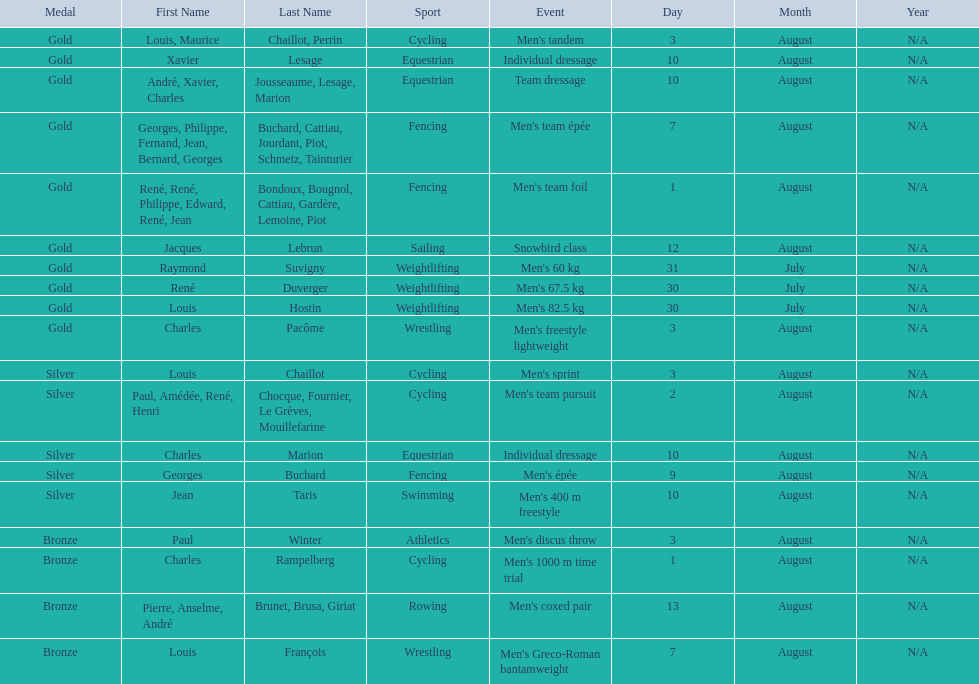What sport is listed first? Cycling. Can you give me this table as a dict? {'header': ['Medal', 'First Name', 'Last Name', 'Sport', 'Event', 'Day', 'Month', 'Year'], 'rows': [['Gold', 'Louis, Maurice', 'Chaillot, Perrin', 'Cycling', "Men's tandem", '3', 'August', 'N/A'], ['Gold', 'Xavier', 'Lesage', 'Equestrian', 'Individual dressage', '10', 'August', 'N/A'], ['Gold', 'André, Xavier, Charles', 'Jousseaume, Lesage, Marion', 'Equestrian', 'Team dressage', '10', 'August', 'N/A'], ['Gold', 'Georges, Philippe, Fernand, Jean, Bernard, Georges', 'Buchard, Cattiau, Jourdant, Piot, Schmetz, Tainturier', 'Fencing', "Men's team épée", '7', 'August', 'N/A'], ['Gold', 'René, René, Philippe, Edward, René, Jean', 'Bondoux, Bougnol, Cattiau, Gardère, Lemoine, Piot', 'Fencing', "Men's team foil", '1', 'August', 'N/A'], ['Gold', 'Jacques', 'Lebrun', 'Sailing', 'Snowbird class', '12', 'August', 'N/A'], ['Gold', 'Raymond', 'Suvigny', 'Weightlifting', "Men's 60 kg", '31', 'July', 'N/A'], ['Gold', 'René', 'Duverger', 'Weightlifting', "Men's 67.5 kg", '30', 'July', 'N/A'], ['Gold', 'Louis', 'Hostin', 'Weightlifting', "Men's 82.5 kg", '30', 'July', 'N/A'], ['Gold', 'Charles', 'Pacôme', 'Wrestling', "Men's freestyle lightweight", '3', 'August', 'N/A'], ['Silver', 'Louis', 'Chaillot', 'Cycling', "Men's sprint", '3', 'August', 'N/A'], ['Silver', 'Paul, Amédée, René, Henri', 'Chocque, Fournier, Le Grèves, Mouillefarine', 'Cycling', "Men's team pursuit", '2', 'August', 'N/A'], ['Silver', 'Charles', 'Marion', 'Equestrian', 'Individual dressage', '10', 'August', 'N/A'], ['Silver', 'Georges', 'Buchard', 'Fencing', "Men's épée", '9', 'August', 'N/A'], ['Silver', 'Jean', 'Taris', 'Swimming', "Men's 400 m freestyle", '10', 'August', 'N/A'], ['Bronze', 'Paul', 'Winter', 'Athletics', "Men's discus throw", '3', 'August', 'N/A'], ['Bronze', 'Charles', 'Rampelberg', 'Cycling', "Men's 1000 m time trial", '1', 'August', 'N/A'], ['Bronze', 'Pierre, Anselme, André', 'Brunet, Brusa, Giriat', 'Rowing', "Men's coxed pair", '13', 'August', 'N/A'], ['Bronze', 'Louis', 'François', 'Wrestling', "Men's Greco-Roman bantamweight", '7', 'August', 'N/A']]} 